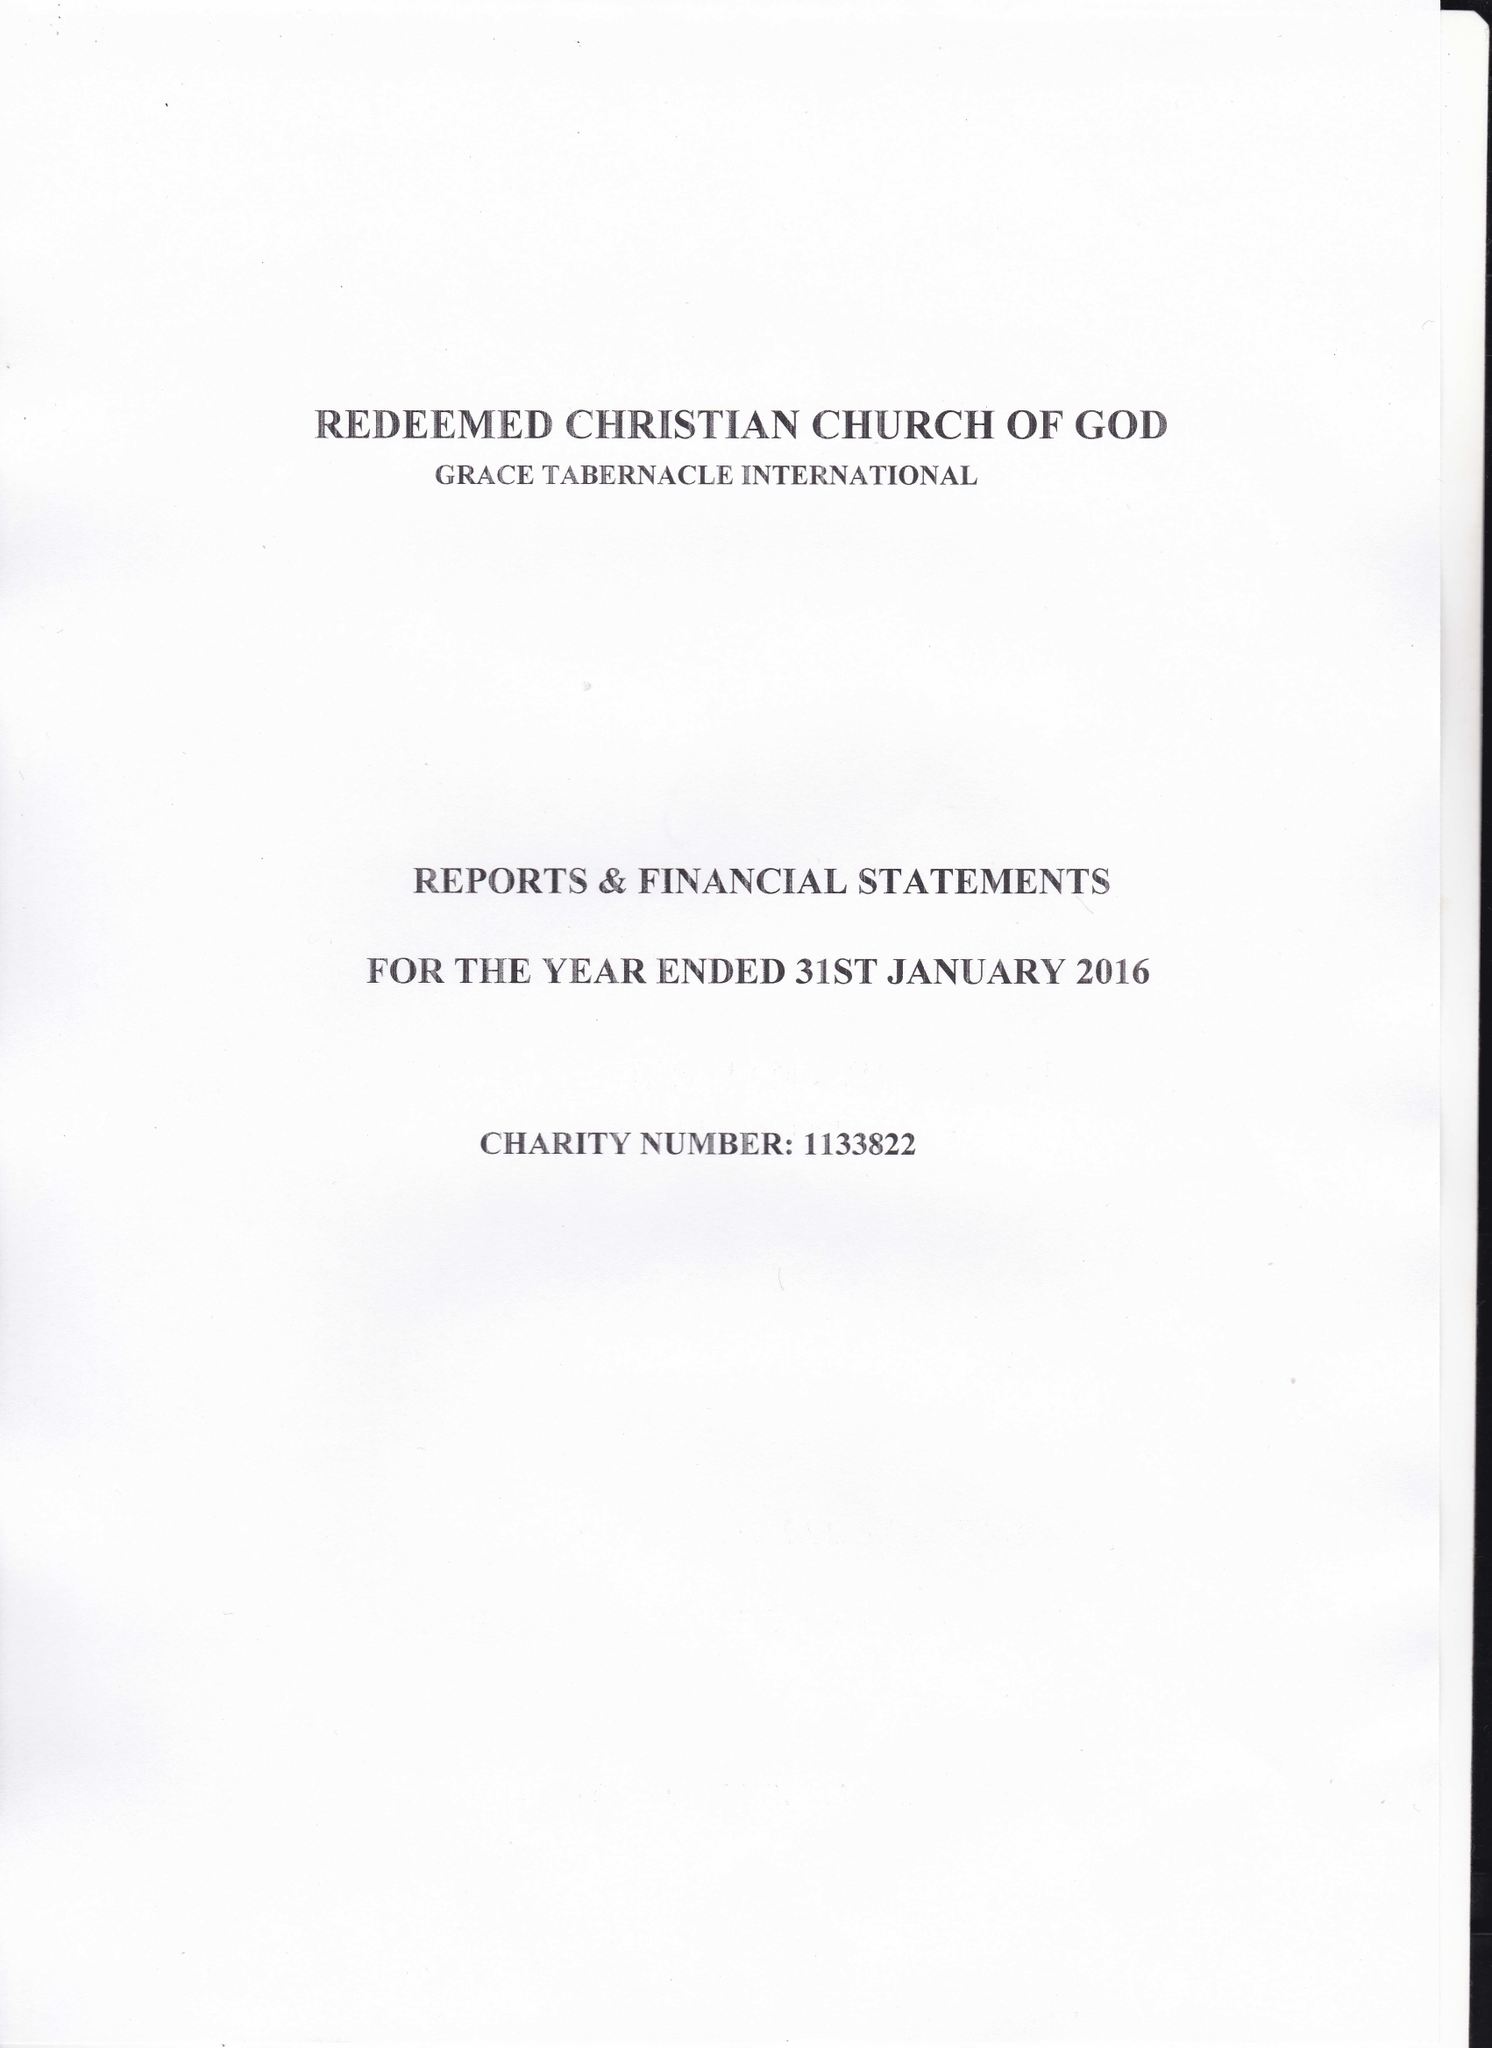What is the value for the address__postcode?
Answer the question using a single word or phrase. CR0 3AA 